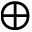Convert formula to latex. <formula><loc_0><loc_0><loc_500><loc_500>\oplus</formula> 